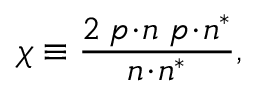<formula> <loc_0><loc_0><loc_500><loc_500>\chi \equiv \frac { 2 \, p \, \cdot \, n \, p \, \cdot \, n ^ { \ast } } { n \, \cdot \, n ^ { \ast } } ,</formula> 